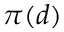Convert formula to latex. <formula><loc_0><loc_0><loc_500><loc_500>\pi ( d )</formula> 